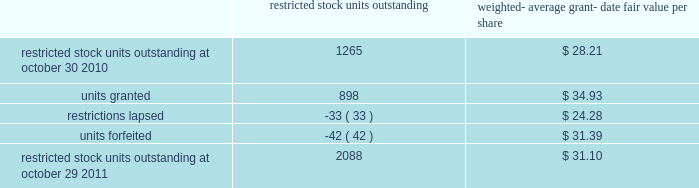The total intrinsic value of options exercised ( i.e .
The difference between the market price at exercise and the price paid by the employee to exercise the options ) during fiscal 2011 , 2010 and 2009 was $ 96.5 million , $ 29.6 million and $ 4.7 million , respectively .
The total amount of proceeds received by the company from exercise of these options during fiscal 2011 , 2010 and 2009 was $ 217.4 million , $ 240.4 million and $ 15.1 million , respectively .
Proceeds from stock option exercises pursuant to employee stock plans in the company 2019s statement of cash flows of $ 217.2 million , $ 216.1 million and $ 12.4 million for fiscal 2011 , 2010 and 2009 , respectively , are net of the value of shares surrendered by employees in certain limited circumstances to satisfy the exercise price of options , and to satisfy employee tax obligations upon vesting of restricted stock or restricted stock units and in connection with the exercise of stock options granted to the company 2019s employees under the company 2019s equity compensation plans .
The withholding amount is based on the company 2019s minimum statutory withholding requirement .
A summary of the company 2019s restricted stock unit award activity as of october 29 , 2011 and changes during the year then ended is presented below : restricted outstanding weighted- average grant- date fair value per share .
As of october 29 , 2011 , there was $ 88.6 million of total unrecognized compensation cost related to unvested share-based awards comprised of stock options and restricted stock units .
That cost is expected to be recognized over a weighted-average period of 1.3 years .
The total grant-date fair value of shares that vested during fiscal 2011 , 2010 and 2009 was approximately $ 49.6 million , $ 67.7 million and $ 74.4 million , respectively .
Common stock repurchase program the company 2019s common stock repurchase program has been in place since august 2004 .
In the aggregate , the board of directors has authorized the company to repurchase $ 5 billion of the company 2019s common stock under the program .
Under the program , the company may repurchase outstanding shares of its common stock from time to time in the open market and through privately negotiated transactions .
Unless terminated earlier by resolution of the company 2019s board of directors , the repurchase program will expire when the company has repurchased all shares authorized under the program .
As of october 29 , 2011 , the company had repurchased a total of approximately 125.0 million shares of its common stock for approximately $ 4278.5 million under this program .
An additional $ 721.5 million remains available for repurchase of shares under the current authorized program .
The repurchased shares are held as authorized but unissued shares of common stock .
Any future common stock repurchases will be dependent upon several factors , including the amount of cash available to the company in the united states and the company 2019s financial performance , outlook and liquidity .
The company also from time to time repurchases shares in settlement of employee tax withholding obligations due upon the vesting of restricted stock units , or in certain limited circumstances to satisfy the exercise price of options granted to the company 2019s employees under the company 2019s equity compensation plans .
Analog devices , inc .
Notes to consolidated financial statements 2014 ( continued ) .
What is the total fair value of restricted stock units outstanding at october 29 , 2011? 
Computations: (2088 * 31.10)
Answer: 64936.8. 